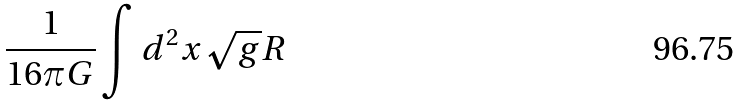<formula> <loc_0><loc_0><loc_500><loc_500>\frac { 1 } { 1 6 \pi G } \int d ^ { 2 } x \sqrt { g } R</formula> 